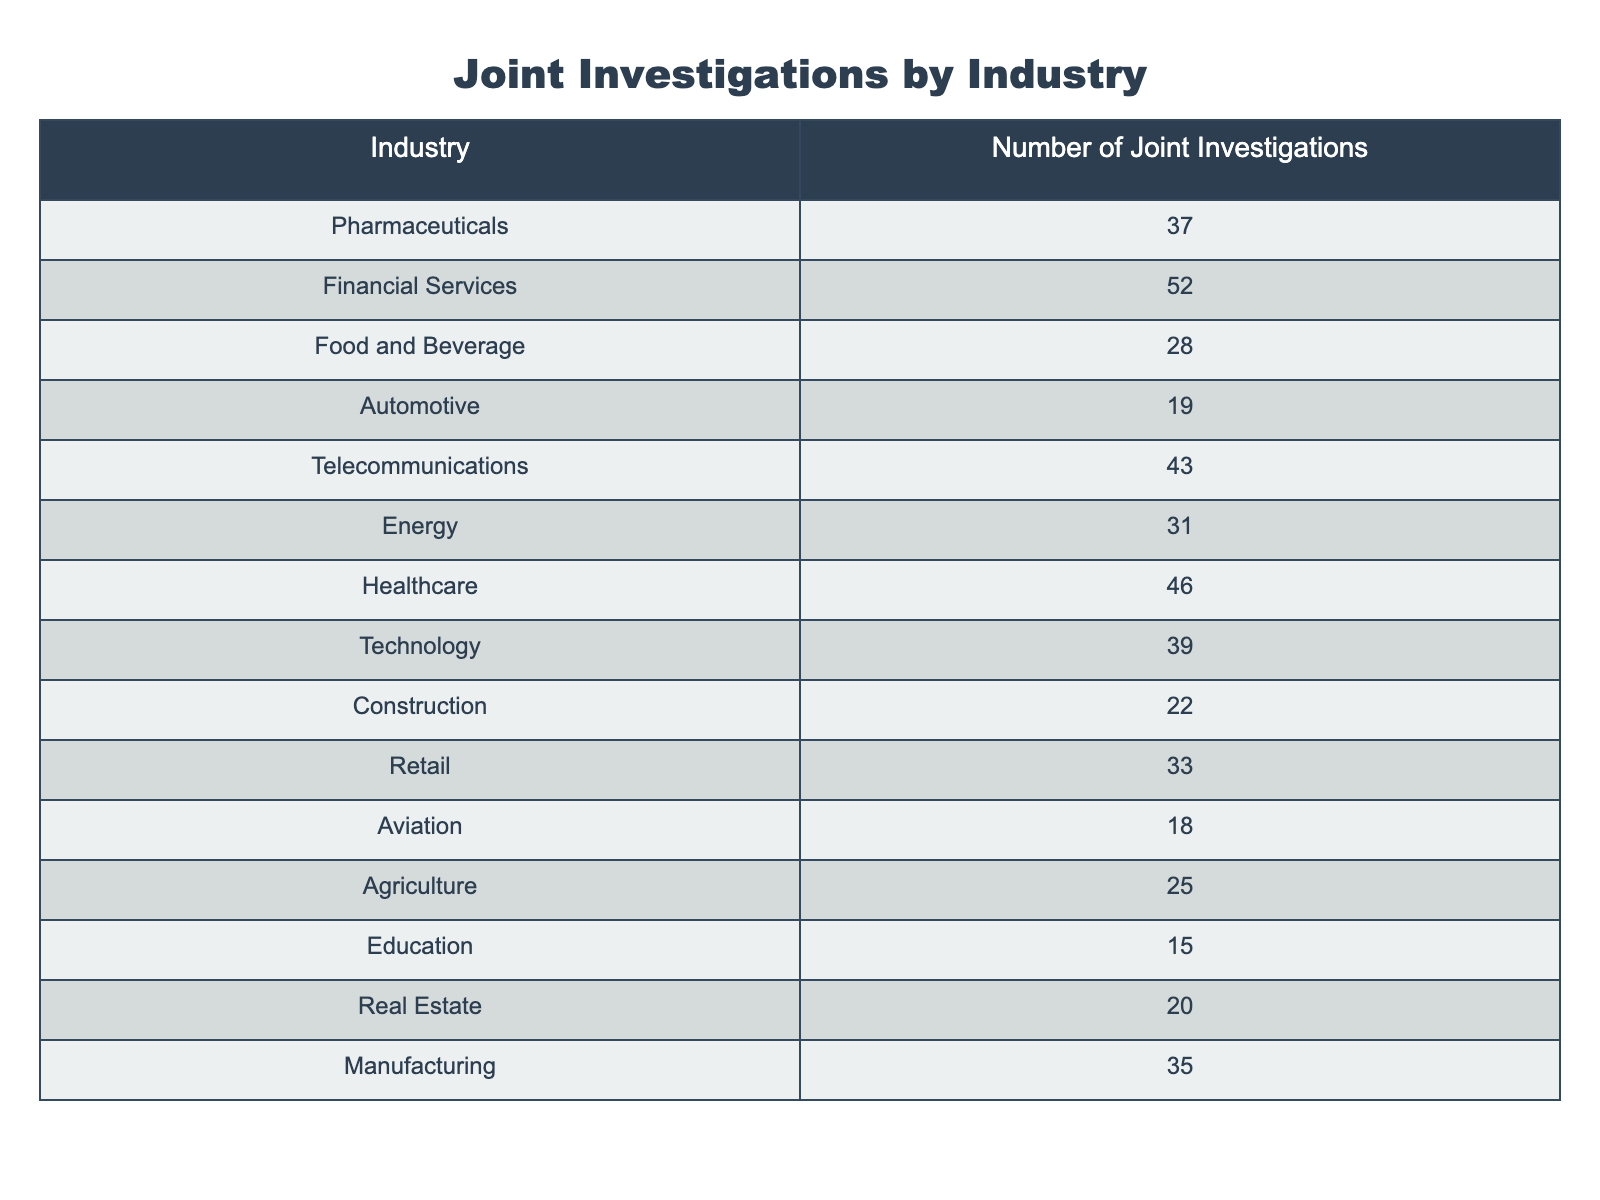What is the industry with the highest number of joint investigations? By looking at the table, the highest value is 52, which belongs to the Financial Services industry.
Answer: Financial Services How many joint investigations were conducted in the Healthcare industry? The table shows that the number of joint investigations for Healthcare is 46.
Answer: 46 What is the total number of joint investigations across all industries? Adding all the values in the table: 37 + 52 + 28 + 19 + 43 + 31 + 46 + 39 + 22 + 33 + 18 + 25 + 15 + 20 + 35 =  449.
Answer: 449 Which industry has fewer joint investigations: Aviation or Automotive? The table shows Aviation has 18 and Automotive has 19. Since 18 < 19, Aviation has fewer joint investigations.
Answer: Aviation What is the average number of joint investigations across the industries listed? There are 15 industries listed. The total is 449. To find the average, divide 449 by 15: 449 / 15 = 29.93, rounded to 30.
Answer: 30 Which two industries have the lowest number of joint investigations? The table indicates that the industries with the lowest numbers are Education with 15 and Aviation with 18.
Answer: Education and Aviation Is it true that the Technology industry had more joint investigations than the Energy industry? The table indicates Technology had 39 and Energy had 31. Since 39 > 31, this statement is true.
Answer: True What is the difference between the highest and lowest number of joint investigations? The highest is 52 (Financial Services) and the lowest is 15 (Education). The difference is 52 - 15 = 37.
Answer: 37 How many industries conducted joint investigations above the average? The average number is 30. Counting the industries with numbers above this, we have: Pharmaceuticals (37), Financial Services (52), Healthcare (46), Technology (39), Telecommunications (43), and Energy (31), totaling 6 industries.
Answer: 6 Which industry has a number of joint investigations that is more than 40 but less than 50? The industries fitting this criterion are Healthcare (46) and Telecommunications (43).
Answer: Healthcare and Telecommunications 